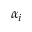<formula> <loc_0><loc_0><loc_500><loc_500>\alpha _ { i }</formula> 